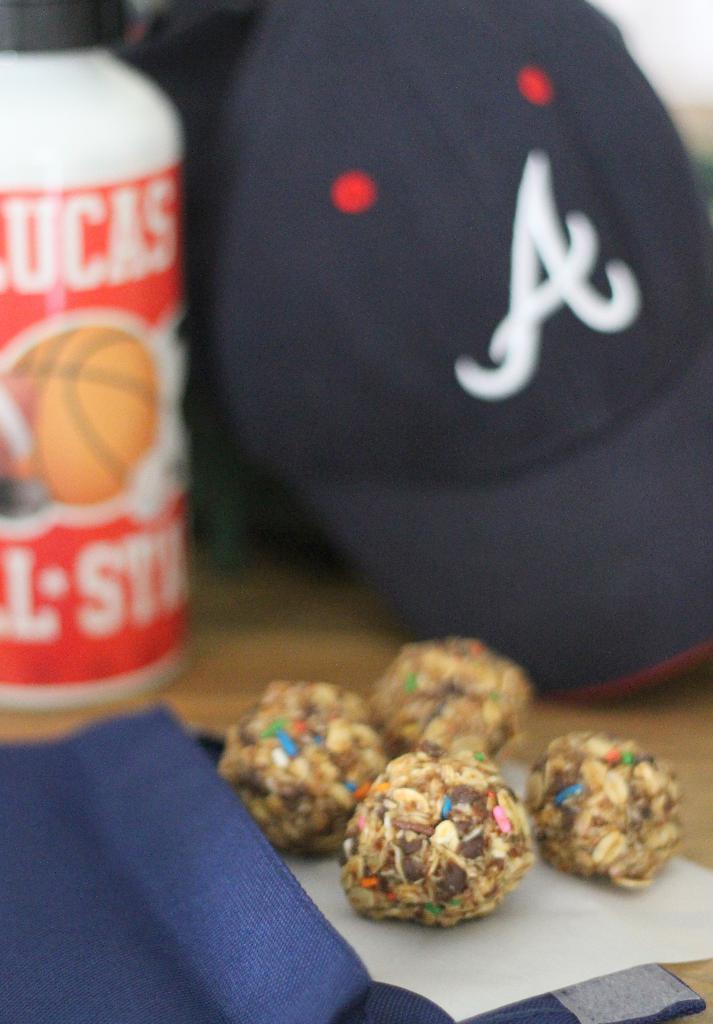Please provide a concise description of this image. We can see food,cap,bottle and objects on the surface. 